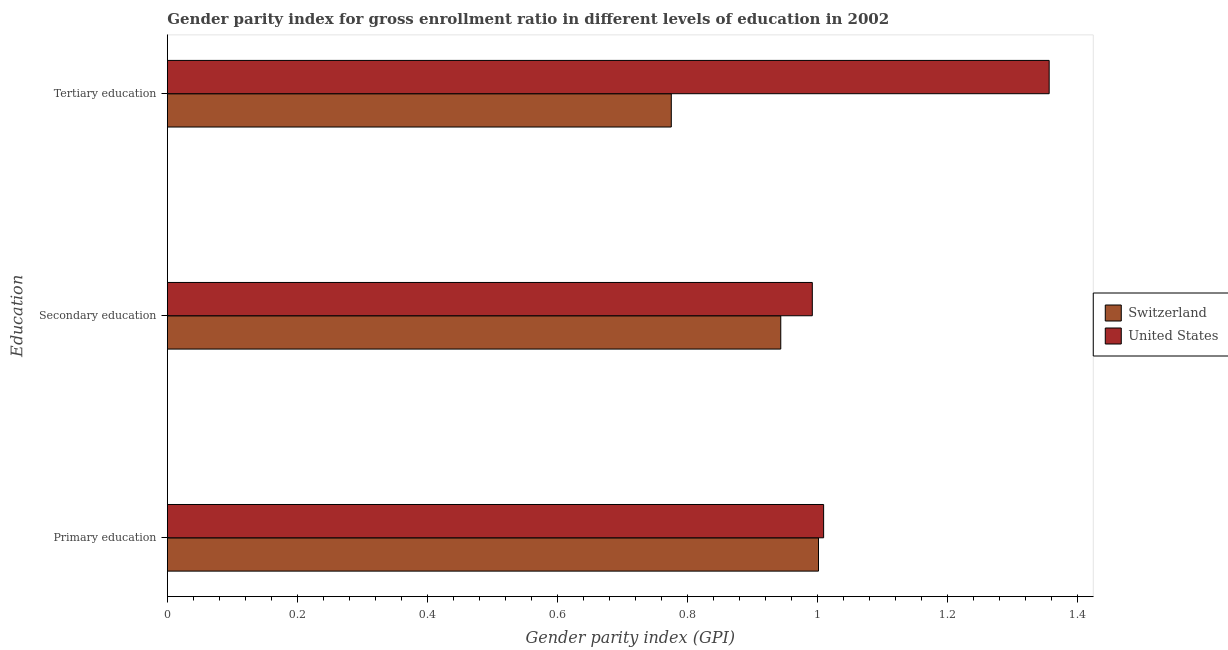Are the number of bars on each tick of the Y-axis equal?
Keep it short and to the point. Yes. How many bars are there on the 3rd tick from the top?
Give a very brief answer. 2. How many bars are there on the 3rd tick from the bottom?
Your response must be concise. 2. What is the gender parity index in secondary education in Switzerland?
Keep it short and to the point. 0.94. Across all countries, what is the maximum gender parity index in secondary education?
Make the answer very short. 0.99. Across all countries, what is the minimum gender parity index in primary education?
Offer a terse response. 1. In which country was the gender parity index in tertiary education minimum?
Keep it short and to the point. Switzerland. What is the total gender parity index in primary education in the graph?
Your answer should be very brief. 2.01. What is the difference between the gender parity index in tertiary education in Switzerland and that in United States?
Your answer should be compact. -0.58. What is the difference between the gender parity index in tertiary education in United States and the gender parity index in secondary education in Switzerland?
Your response must be concise. 0.41. What is the average gender parity index in secondary education per country?
Ensure brevity in your answer.  0.97. What is the difference between the gender parity index in tertiary education and gender parity index in primary education in United States?
Ensure brevity in your answer.  0.35. In how many countries, is the gender parity index in secondary education greater than 0.56 ?
Your response must be concise. 2. What is the ratio of the gender parity index in primary education in United States to that in Switzerland?
Offer a very short reply. 1.01. Is the gender parity index in tertiary education in Switzerland less than that in United States?
Your response must be concise. Yes. Is the difference between the gender parity index in primary education in Switzerland and United States greater than the difference between the gender parity index in secondary education in Switzerland and United States?
Make the answer very short. Yes. What is the difference between the highest and the second highest gender parity index in secondary education?
Provide a succinct answer. 0.05. What is the difference between the highest and the lowest gender parity index in tertiary education?
Keep it short and to the point. 0.58. In how many countries, is the gender parity index in primary education greater than the average gender parity index in primary education taken over all countries?
Make the answer very short. 1. Is the sum of the gender parity index in primary education in Switzerland and United States greater than the maximum gender parity index in secondary education across all countries?
Your answer should be very brief. Yes. What does the 2nd bar from the top in Primary education represents?
Make the answer very short. Switzerland. What does the 1st bar from the bottom in Primary education represents?
Offer a terse response. Switzerland. Are all the bars in the graph horizontal?
Offer a terse response. Yes. How many countries are there in the graph?
Offer a very short reply. 2. What is the difference between two consecutive major ticks on the X-axis?
Make the answer very short. 0.2. Does the graph contain any zero values?
Provide a succinct answer. No. Does the graph contain grids?
Provide a succinct answer. No. What is the title of the graph?
Provide a succinct answer. Gender parity index for gross enrollment ratio in different levels of education in 2002. Does "Europe(all income levels)" appear as one of the legend labels in the graph?
Ensure brevity in your answer.  No. What is the label or title of the X-axis?
Make the answer very short. Gender parity index (GPI). What is the label or title of the Y-axis?
Your response must be concise. Education. What is the Gender parity index (GPI) of Switzerland in Primary education?
Your answer should be very brief. 1. What is the Gender parity index (GPI) in United States in Primary education?
Keep it short and to the point. 1.01. What is the Gender parity index (GPI) in Switzerland in Secondary education?
Your response must be concise. 0.94. What is the Gender parity index (GPI) of United States in Secondary education?
Ensure brevity in your answer.  0.99. What is the Gender parity index (GPI) of Switzerland in Tertiary education?
Your response must be concise. 0.78. What is the Gender parity index (GPI) in United States in Tertiary education?
Make the answer very short. 1.36. Across all Education, what is the maximum Gender parity index (GPI) of Switzerland?
Keep it short and to the point. 1. Across all Education, what is the maximum Gender parity index (GPI) in United States?
Give a very brief answer. 1.36. Across all Education, what is the minimum Gender parity index (GPI) of Switzerland?
Make the answer very short. 0.78. Across all Education, what is the minimum Gender parity index (GPI) of United States?
Make the answer very short. 0.99. What is the total Gender parity index (GPI) of Switzerland in the graph?
Ensure brevity in your answer.  2.72. What is the total Gender parity index (GPI) of United States in the graph?
Provide a succinct answer. 3.36. What is the difference between the Gender parity index (GPI) of Switzerland in Primary education and that in Secondary education?
Make the answer very short. 0.06. What is the difference between the Gender parity index (GPI) of United States in Primary education and that in Secondary education?
Make the answer very short. 0.02. What is the difference between the Gender parity index (GPI) in Switzerland in Primary education and that in Tertiary education?
Your answer should be compact. 0.23. What is the difference between the Gender parity index (GPI) in United States in Primary education and that in Tertiary education?
Offer a terse response. -0.35. What is the difference between the Gender parity index (GPI) of Switzerland in Secondary education and that in Tertiary education?
Offer a very short reply. 0.17. What is the difference between the Gender parity index (GPI) in United States in Secondary education and that in Tertiary education?
Keep it short and to the point. -0.36. What is the difference between the Gender parity index (GPI) of Switzerland in Primary education and the Gender parity index (GPI) of United States in Secondary education?
Provide a short and direct response. 0.01. What is the difference between the Gender parity index (GPI) in Switzerland in Primary education and the Gender parity index (GPI) in United States in Tertiary education?
Your answer should be very brief. -0.35. What is the difference between the Gender parity index (GPI) in Switzerland in Secondary education and the Gender parity index (GPI) in United States in Tertiary education?
Offer a terse response. -0.41. What is the average Gender parity index (GPI) of Switzerland per Education?
Make the answer very short. 0.91. What is the average Gender parity index (GPI) in United States per Education?
Make the answer very short. 1.12. What is the difference between the Gender parity index (GPI) in Switzerland and Gender parity index (GPI) in United States in Primary education?
Your answer should be very brief. -0.01. What is the difference between the Gender parity index (GPI) of Switzerland and Gender parity index (GPI) of United States in Secondary education?
Your response must be concise. -0.05. What is the difference between the Gender parity index (GPI) of Switzerland and Gender parity index (GPI) of United States in Tertiary education?
Your answer should be compact. -0.58. What is the ratio of the Gender parity index (GPI) of Switzerland in Primary education to that in Secondary education?
Provide a succinct answer. 1.06. What is the ratio of the Gender parity index (GPI) of United States in Primary education to that in Secondary education?
Your response must be concise. 1.02. What is the ratio of the Gender parity index (GPI) in Switzerland in Primary education to that in Tertiary education?
Provide a succinct answer. 1.29. What is the ratio of the Gender parity index (GPI) in United States in Primary education to that in Tertiary education?
Give a very brief answer. 0.74. What is the ratio of the Gender parity index (GPI) in Switzerland in Secondary education to that in Tertiary education?
Offer a very short reply. 1.22. What is the ratio of the Gender parity index (GPI) in United States in Secondary education to that in Tertiary education?
Ensure brevity in your answer.  0.73. What is the difference between the highest and the second highest Gender parity index (GPI) of Switzerland?
Ensure brevity in your answer.  0.06. What is the difference between the highest and the second highest Gender parity index (GPI) in United States?
Ensure brevity in your answer.  0.35. What is the difference between the highest and the lowest Gender parity index (GPI) in Switzerland?
Your answer should be compact. 0.23. What is the difference between the highest and the lowest Gender parity index (GPI) in United States?
Ensure brevity in your answer.  0.36. 